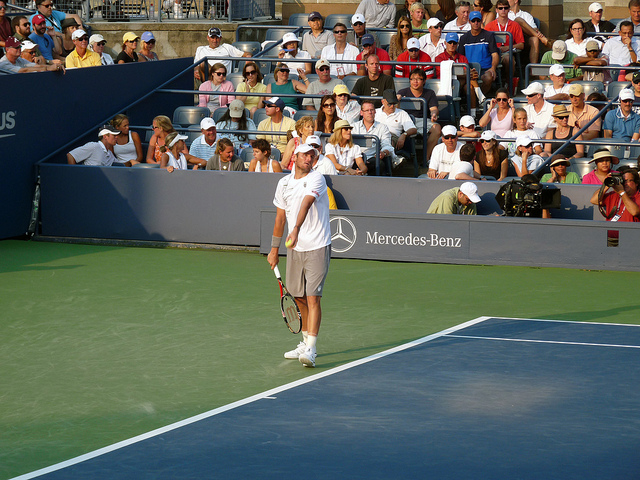Read all the text in this image. Mercedes- -BENZ 